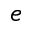<formula> <loc_0><loc_0><loc_500><loc_500>e</formula> 